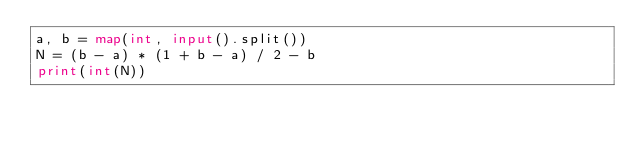<code> <loc_0><loc_0><loc_500><loc_500><_Python_>a, b = map(int, input().split())
N = (b - a) * (1 + b - a) / 2 - b
print(int(N))</code> 